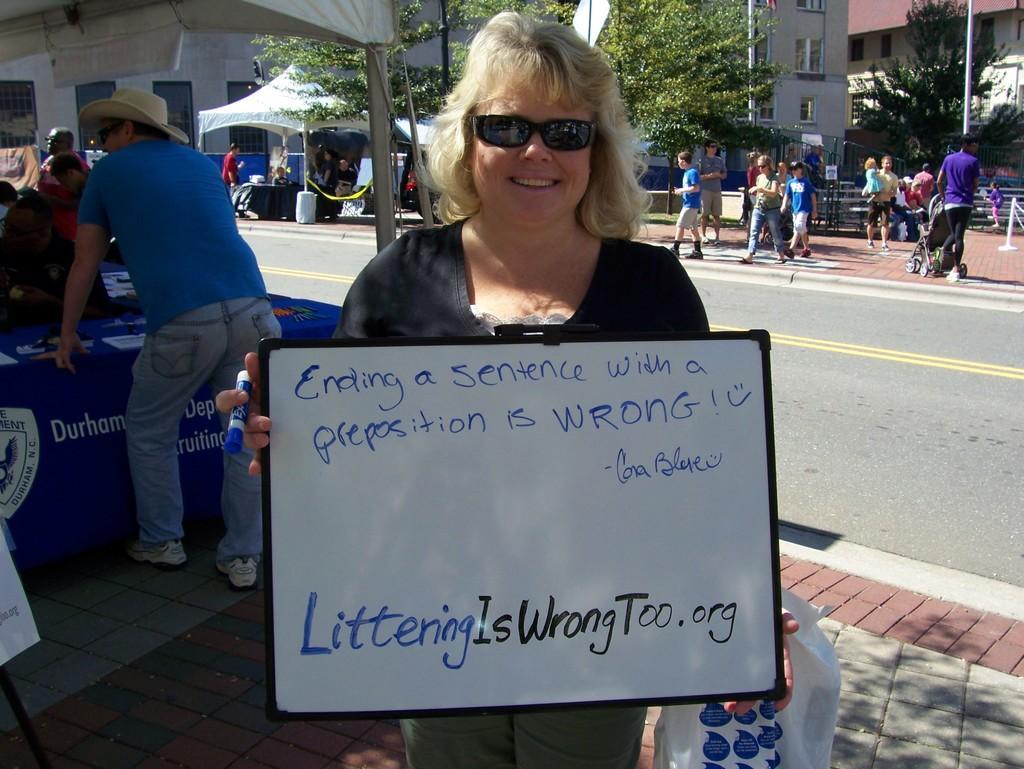How would you summarize this image in a sentence or two? In this image we can see a woman standing on the ground holding a marker and a board with some text on it. We can also see a can also see a cover, a board on a stand and a group of people standing on the ground. In that a man is holding a baby carrier. We can also see a table with some papers on it, some people under the tents, poles, buildings with windows, a barrier with a ribbon, a fence, a group of trees and the pathway. 